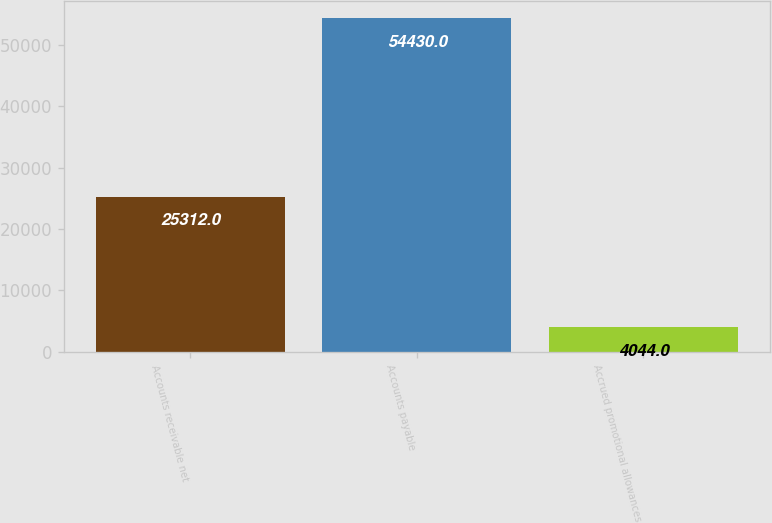<chart> <loc_0><loc_0><loc_500><loc_500><bar_chart><fcel>Accounts receivable net<fcel>Accounts payable<fcel>Accrued promotional allowances<nl><fcel>25312<fcel>54430<fcel>4044<nl></chart> 